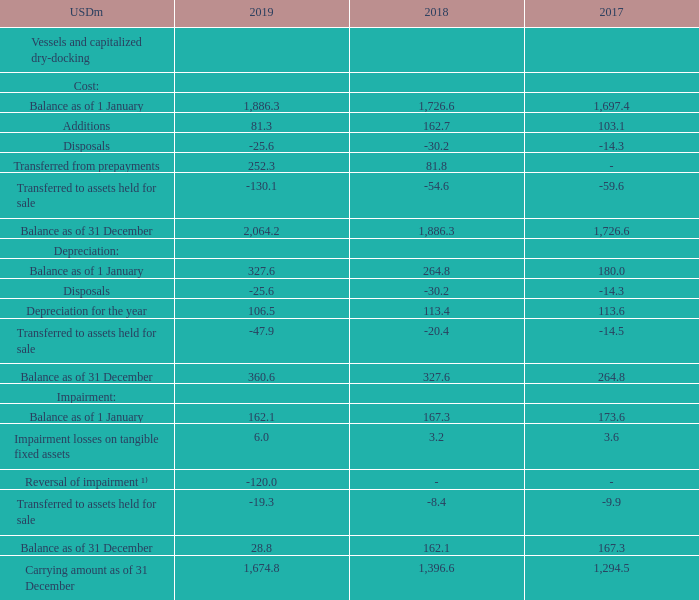NOTE 6- continued
¹⁾ For additional information regarding impairment considerations, please refer to note 8.
Included in the carrying amount for "Vessels and capitalized dry-docking" are capitalized drydocking costs in the amount of USD 60.7m (2018: USD 67.5m, 2017: USD 68.1m).
The sale and leaseback transactions in 2019 were all classified as financing arrangements and did not result in derecognition of the underlying assets as control was retained by the Group.
Under reversal of impairment, where can additional information regarding impairment considerations be found? Refer to note 8. What is included in the carrying amount for "Vessels and capitalized dry-docking"? Capitalized drydocking costs. What are the sub-elements under Vessels and capitalized dry-docking in the table? Cost, depreciation, impairment. In which year was the impairment losses on tangible fixed assets the largest? 6.0>3.6>3.2
Answer: 2019. What was the change in Additions in 2019 from 2018?
Answer scale should be: million. 81.3-162.7
Answer: -81.4. What was the percentage change in Additions in 2019 from 2018?
Answer scale should be: percent. (81.3-162.7)/162.7
Answer: -50.03. 